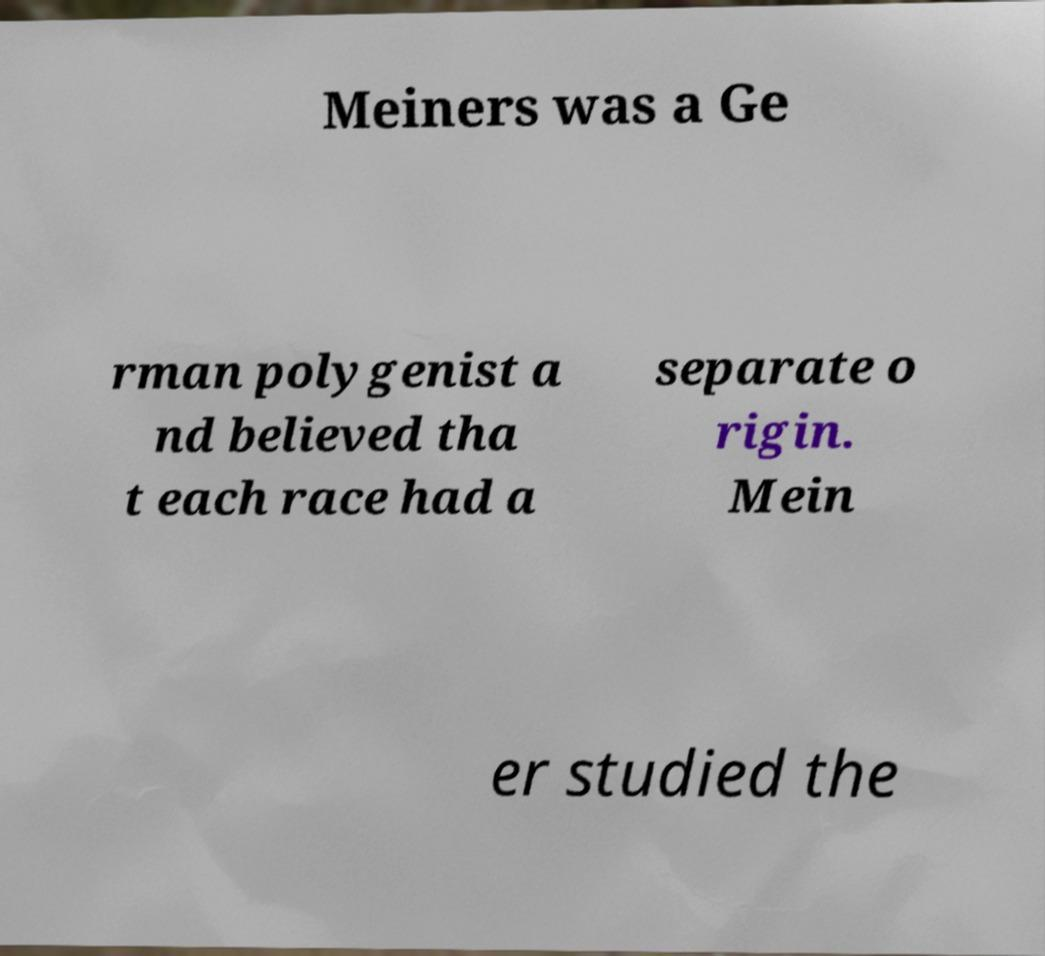There's text embedded in this image that I need extracted. Can you transcribe it verbatim? Meiners was a Ge rman polygenist a nd believed tha t each race had a separate o rigin. Mein er studied the 